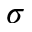Convert formula to latex. <formula><loc_0><loc_0><loc_500><loc_500>\sigma</formula> 